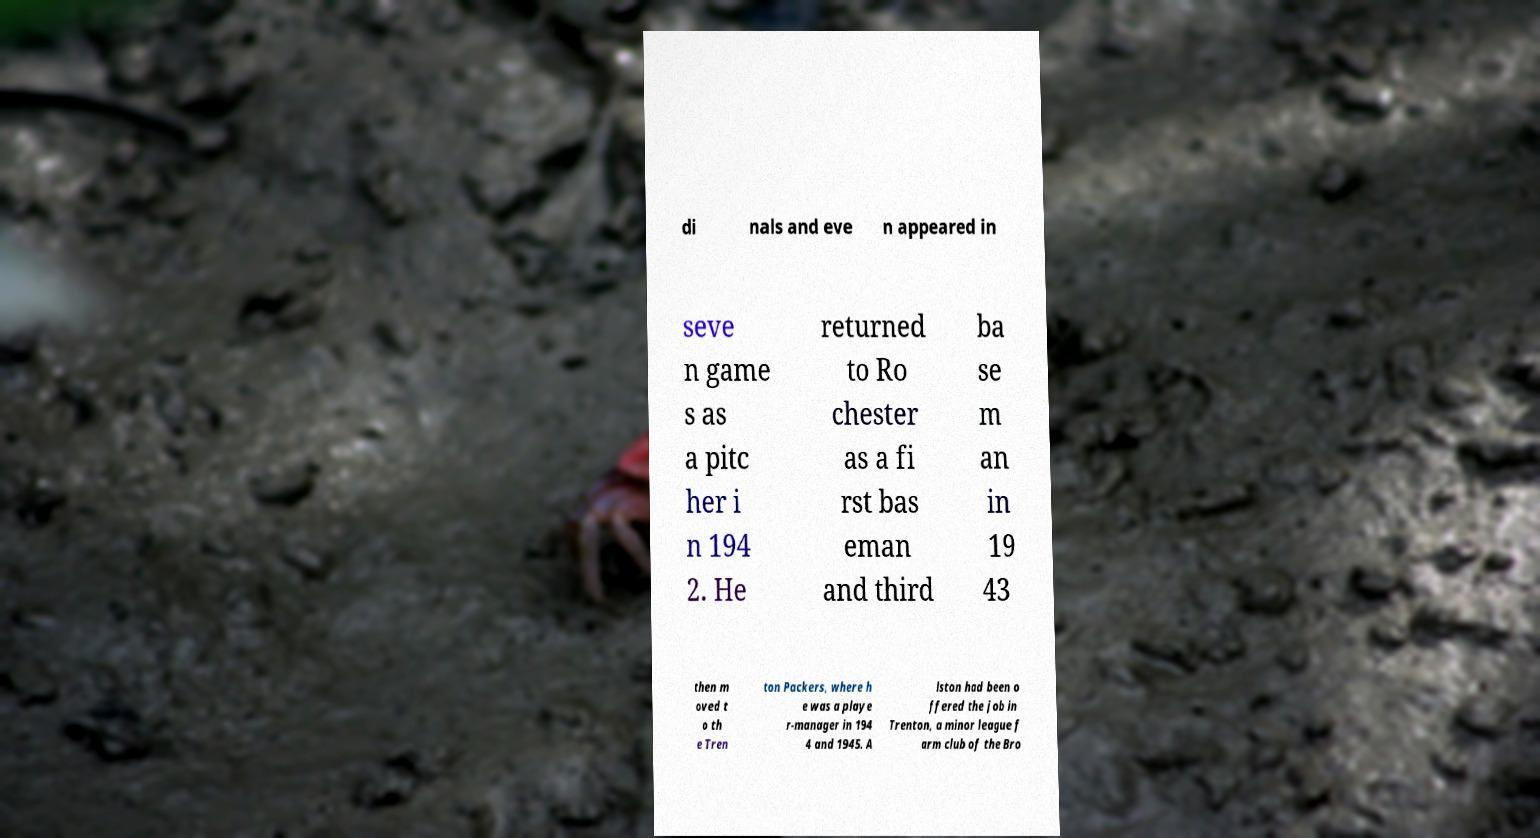For documentation purposes, I need the text within this image transcribed. Could you provide that? di nals and eve n appeared in seve n game s as a pitc her i n 194 2. He returned to Ro chester as a fi rst bas eman and third ba se m an in 19 43 then m oved t o th e Tren ton Packers, where h e was a playe r-manager in 194 4 and 1945. A lston had been o ffered the job in Trenton, a minor league f arm club of the Bro 